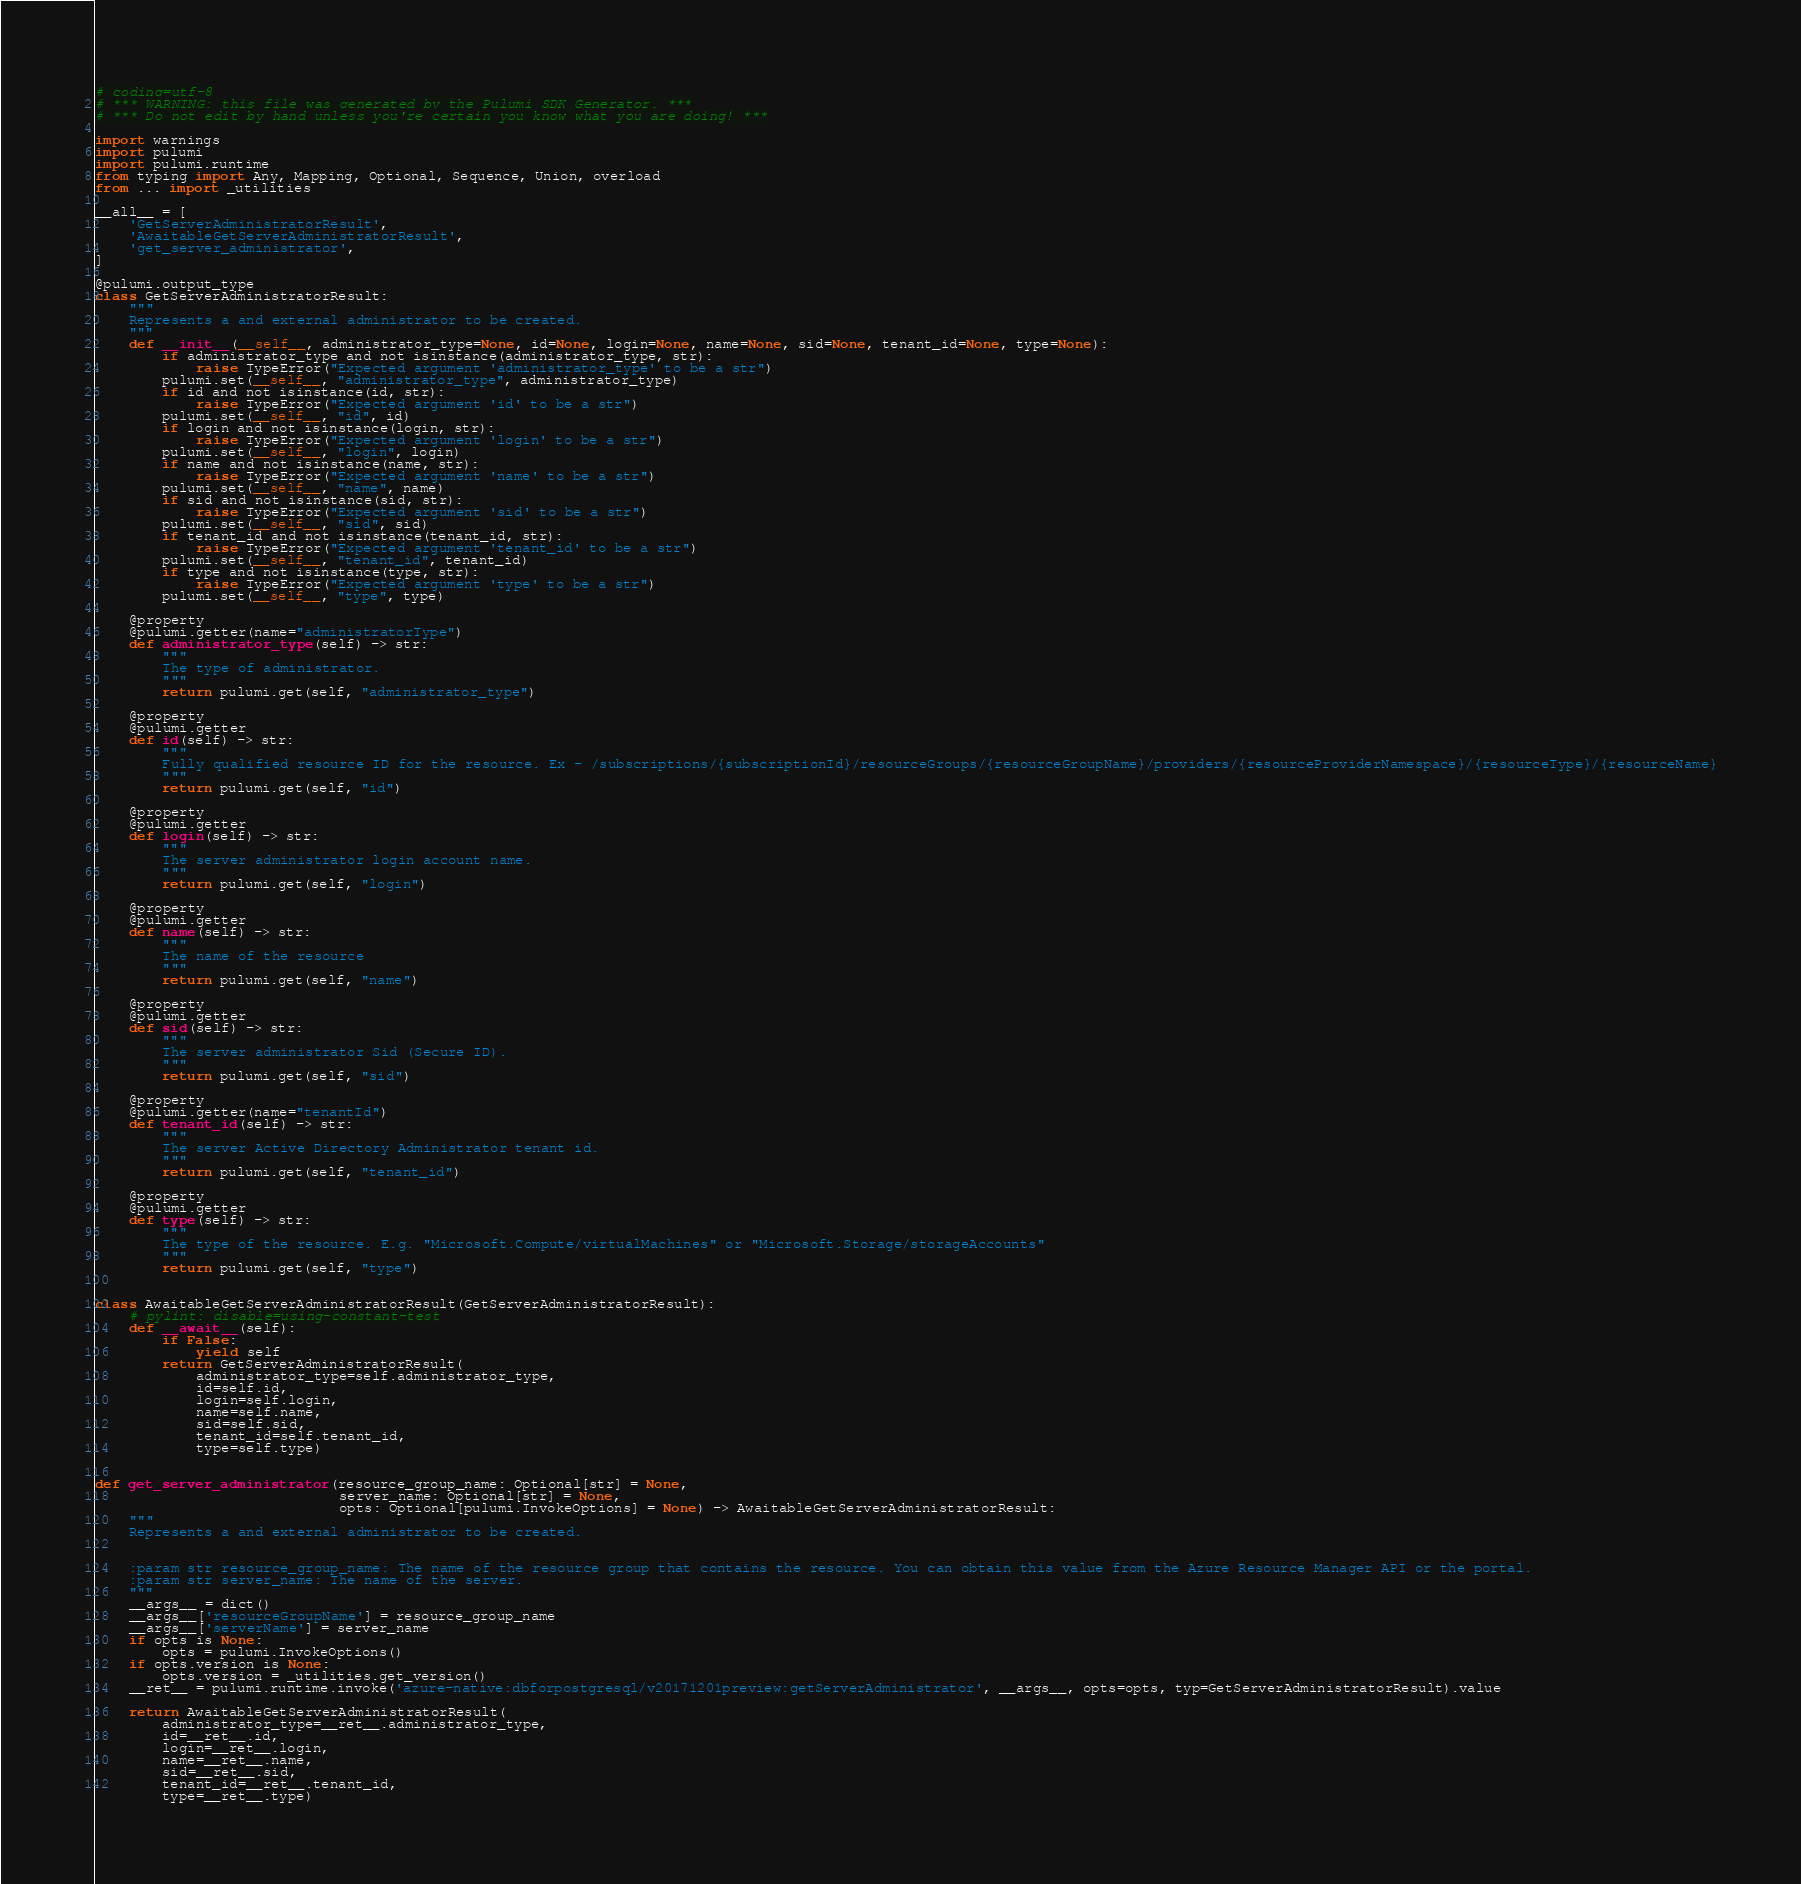Convert code to text. <code><loc_0><loc_0><loc_500><loc_500><_Python_># coding=utf-8
# *** WARNING: this file was generated by the Pulumi SDK Generator. ***
# *** Do not edit by hand unless you're certain you know what you are doing! ***

import warnings
import pulumi
import pulumi.runtime
from typing import Any, Mapping, Optional, Sequence, Union, overload
from ... import _utilities

__all__ = [
    'GetServerAdministratorResult',
    'AwaitableGetServerAdministratorResult',
    'get_server_administrator',
]

@pulumi.output_type
class GetServerAdministratorResult:
    """
    Represents a and external administrator to be created.
    """
    def __init__(__self__, administrator_type=None, id=None, login=None, name=None, sid=None, tenant_id=None, type=None):
        if administrator_type and not isinstance(administrator_type, str):
            raise TypeError("Expected argument 'administrator_type' to be a str")
        pulumi.set(__self__, "administrator_type", administrator_type)
        if id and not isinstance(id, str):
            raise TypeError("Expected argument 'id' to be a str")
        pulumi.set(__self__, "id", id)
        if login and not isinstance(login, str):
            raise TypeError("Expected argument 'login' to be a str")
        pulumi.set(__self__, "login", login)
        if name and not isinstance(name, str):
            raise TypeError("Expected argument 'name' to be a str")
        pulumi.set(__self__, "name", name)
        if sid and not isinstance(sid, str):
            raise TypeError("Expected argument 'sid' to be a str")
        pulumi.set(__self__, "sid", sid)
        if tenant_id and not isinstance(tenant_id, str):
            raise TypeError("Expected argument 'tenant_id' to be a str")
        pulumi.set(__self__, "tenant_id", tenant_id)
        if type and not isinstance(type, str):
            raise TypeError("Expected argument 'type' to be a str")
        pulumi.set(__self__, "type", type)

    @property
    @pulumi.getter(name="administratorType")
    def administrator_type(self) -> str:
        """
        The type of administrator.
        """
        return pulumi.get(self, "administrator_type")

    @property
    @pulumi.getter
    def id(self) -> str:
        """
        Fully qualified resource ID for the resource. Ex - /subscriptions/{subscriptionId}/resourceGroups/{resourceGroupName}/providers/{resourceProviderNamespace}/{resourceType}/{resourceName}
        """
        return pulumi.get(self, "id")

    @property
    @pulumi.getter
    def login(self) -> str:
        """
        The server administrator login account name.
        """
        return pulumi.get(self, "login")

    @property
    @pulumi.getter
    def name(self) -> str:
        """
        The name of the resource
        """
        return pulumi.get(self, "name")

    @property
    @pulumi.getter
    def sid(self) -> str:
        """
        The server administrator Sid (Secure ID).
        """
        return pulumi.get(self, "sid")

    @property
    @pulumi.getter(name="tenantId")
    def tenant_id(self) -> str:
        """
        The server Active Directory Administrator tenant id.
        """
        return pulumi.get(self, "tenant_id")

    @property
    @pulumi.getter
    def type(self) -> str:
        """
        The type of the resource. E.g. "Microsoft.Compute/virtualMachines" or "Microsoft.Storage/storageAccounts"
        """
        return pulumi.get(self, "type")


class AwaitableGetServerAdministratorResult(GetServerAdministratorResult):
    # pylint: disable=using-constant-test
    def __await__(self):
        if False:
            yield self
        return GetServerAdministratorResult(
            administrator_type=self.administrator_type,
            id=self.id,
            login=self.login,
            name=self.name,
            sid=self.sid,
            tenant_id=self.tenant_id,
            type=self.type)


def get_server_administrator(resource_group_name: Optional[str] = None,
                             server_name: Optional[str] = None,
                             opts: Optional[pulumi.InvokeOptions] = None) -> AwaitableGetServerAdministratorResult:
    """
    Represents a and external administrator to be created.


    :param str resource_group_name: The name of the resource group that contains the resource. You can obtain this value from the Azure Resource Manager API or the portal.
    :param str server_name: The name of the server.
    """
    __args__ = dict()
    __args__['resourceGroupName'] = resource_group_name
    __args__['serverName'] = server_name
    if opts is None:
        opts = pulumi.InvokeOptions()
    if opts.version is None:
        opts.version = _utilities.get_version()
    __ret__ = pulumi.runtime.invoke('azure-native:dbforpostgresql/v20171201preview:getServerAdministrator', __args__, opts=opts, typ=GetServerAdministratorResult).value

    return AwaitableGetServerAdministratorResult(
        administrator_type=__ret__.administrator_type,
        id=__ret__.id,
        login=__ret__.login,
        name=__ret__.name,
        sid=__ret__.sid,
        tenant_id=__ret__.tenant_id,
        type=__ret__.type)
</code> 